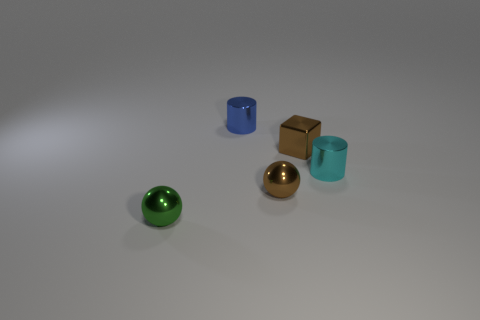The other small object that is the same shape as the cyan shiny thing is what color?
Provide a short and direct response. Blue. Are there more small cyan cylinders behind the tiny green metal ball than cyan cylinders right of the cyan shiny cylinder?
Your answer should be very brief. Yes. What number of other objects are there of the same shape as the small blue metal thing?
Keep it short and to the point. 1. There is a brown object that is behind the small cyan metallic cylinder; is there a small shiny object that is to the right of it?
Ensure brevity in your answer.  Yes. What number of objects are there?
Your answer should be compact. 5. There is a tiny metallic cube; is its color the same as the small metallic ball that is to the right of the small blue object?
Ensure brevity in your answer.  Yes. Is the number of small brown metallic things greater than the number of things?
Your answer should be compact. No. Is there any other thing that is the same color as the metallic cube?
Provide a succinct answer. Yes. What number of other objects are the same size as the cube?
Offer a terse response. 4. Is the material of the tiny brown ball the same as the small object that is on the left side of the blue shiny thing?
Your answer should be very brief. Yes. 